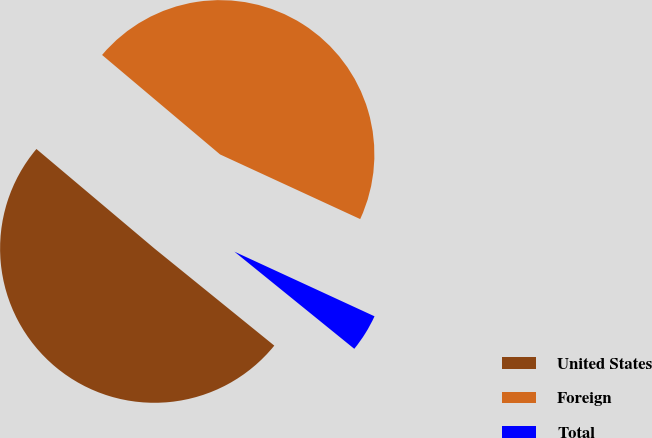<chart> <loc_0><loc_0><loc_500><loc_500><pie_chart><fcel>United States<fcel>Foreign<fcel>Total<nl><fcel>50.31%<fcel>45.73%<fcel>3.96%<nl></chart> 